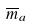Convert formula to latex. <formula><loc_0><loc_0><loc_500><loc_500>\overline { m } _ { a }</formula> 